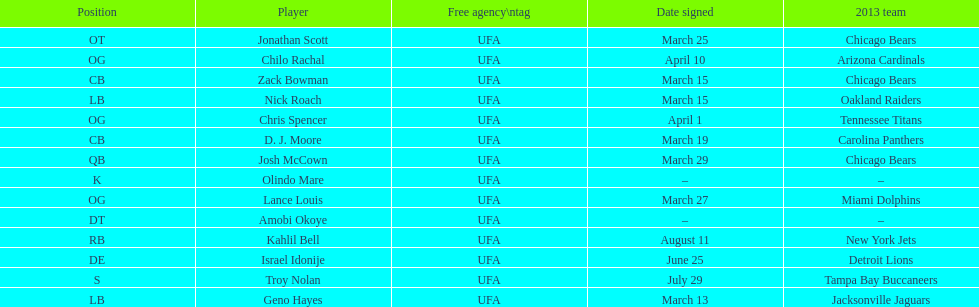His/her first name is the same name as a country. Israel Idonije. 